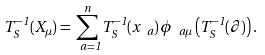Convert formula to latex. <formula><loc_0><loc_0><loc_500><loc_500>T _ { S } ^ { - 1 } ( X _ { \mu } ) = \sum _ { \ a = 1 } ^ { n } T _ { S } ^ { - 1 } ( x _ { \ a } ) \, \phi _ { \ a \mu } \left ( T _ { S } ^ { - 1 } ( \partial ) \right ) .</formula> 